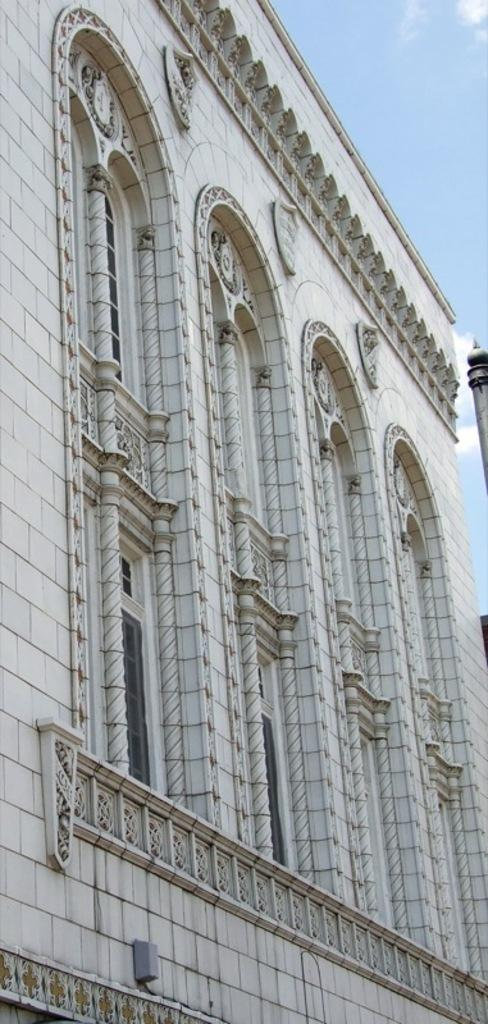What type of structure is present in the image? There is a building in the image. What can be seen above the building in the image? The sky is visible at the top of the image. Who is smiling in the image? There is no person present in the image to smile. 